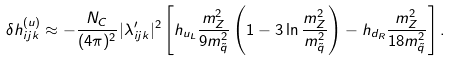<formula> <loc_0><loc_0><loc_500><loc_500>\delta h _ { i j k } ^ { ( u ) } \approx - \frac { N _ { C } } { ( 4 \pi ) ^ { 2 } } | \lambda ^ { \prime } _ { i j k } | ^ { 2 } \left [ h _ { u _ { L } } \frac { m _ { Z } ^ { 2 } } { 9 m _ { \tilde { q } } ^ { 2 } } \left ( 1 - 3 \ln \frac { m _ { Z } ^ { 2 } } { m _ { \tilde { q } } ^ { 2 } } \right ) - h _ { d _ { R } } \frac { m _ { Z } ^ { 2 } } { 1 8 m _ { \tilde { q } } ^ { 2 } } \right ] .</formula> 